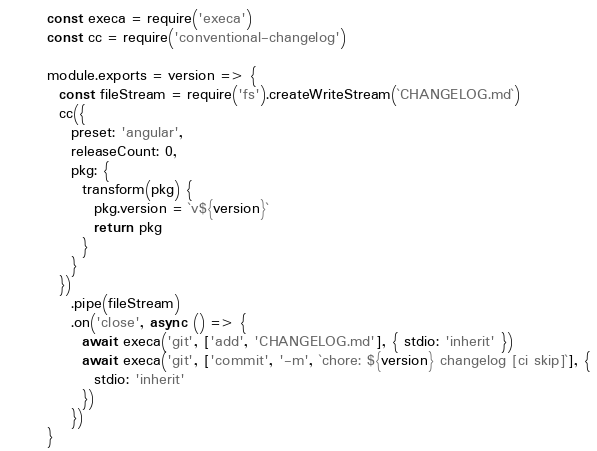Convert code to text. <code><loc_0><loc_0><loc_500><loc_500><_JavaScript_>const execa = require('execa')
const cc = require('conventional-changelog')

module.exports = version => {
  const fileStream = require('fs').createWriteStream(`CHANGELOG.md`)
  cc({
    preset: 'angular',
    releaseCount: 0,
    pkg: {
      transform(pkg) {
        pkg.version = `v${version}`
        return pkg
      }
    }
  })
    .pipe(fileStream)
    .on('close', async () => {
      await execa('git', ['add', 'CHANGELOG.md'], { stdio: 'inherit' })
      await execa('git', ['commit', '-m', `chore: ${version} changelog [ci skip]`], {
        stdio: 'inherit'
      })
    })
}
</code> 